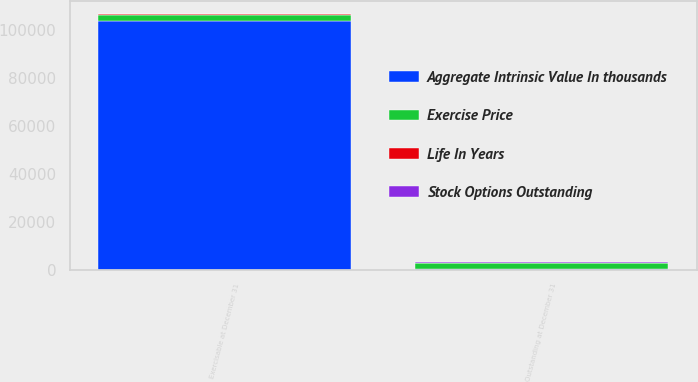Convert chart. <chart><loc_0><loc_0><loc_500><loc_500><stacked_bar_chart><ecel><fcel>Outstanding at December 31<fcel>Exercisable at December 31<nl><fcel>Aggregate Intrinsic Value In thousands<fcel>157.98<fcel>103725<nl><fcel>Stock Options Outstanding<fcel>157.98<fcel>121.11<nl><fcel>Life In Years<fcel>5.3<fcel>5.3<nl><fcel>Exercise Price<fcel>2739<fcel>2737<nl></chart> 